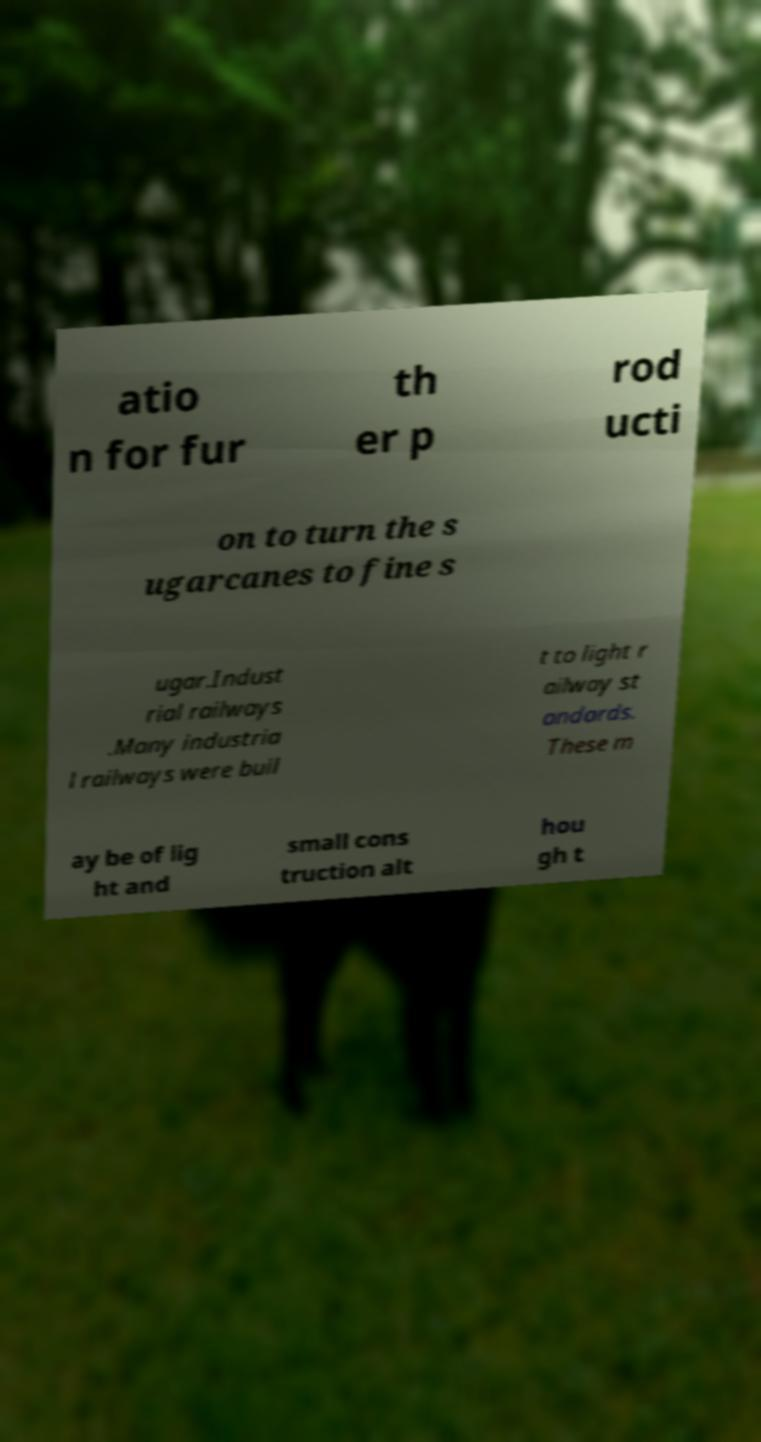I need the written content from this picture converted into text. Can you do that? atio n for fur th er p rod ucti on to turn the s ugarcanes to fine s ugar.Indust rial railways .Many industria l railways were buil t to light r ailway st andards. These m ay be of lig ht and small cons truction alt hou gh t 